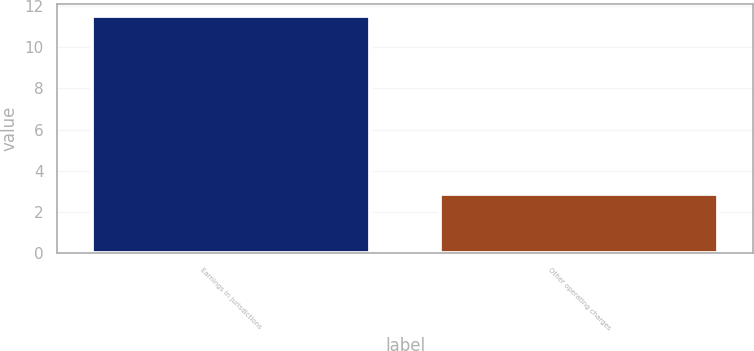<chart> <loc_0><loc_0><loc_500><loc_500><bar_chart><fcel>Earnings in jurisdictions<fcel>Other operating charges<nl><fcel>11.5<fcel>2.9<nl></chart> 